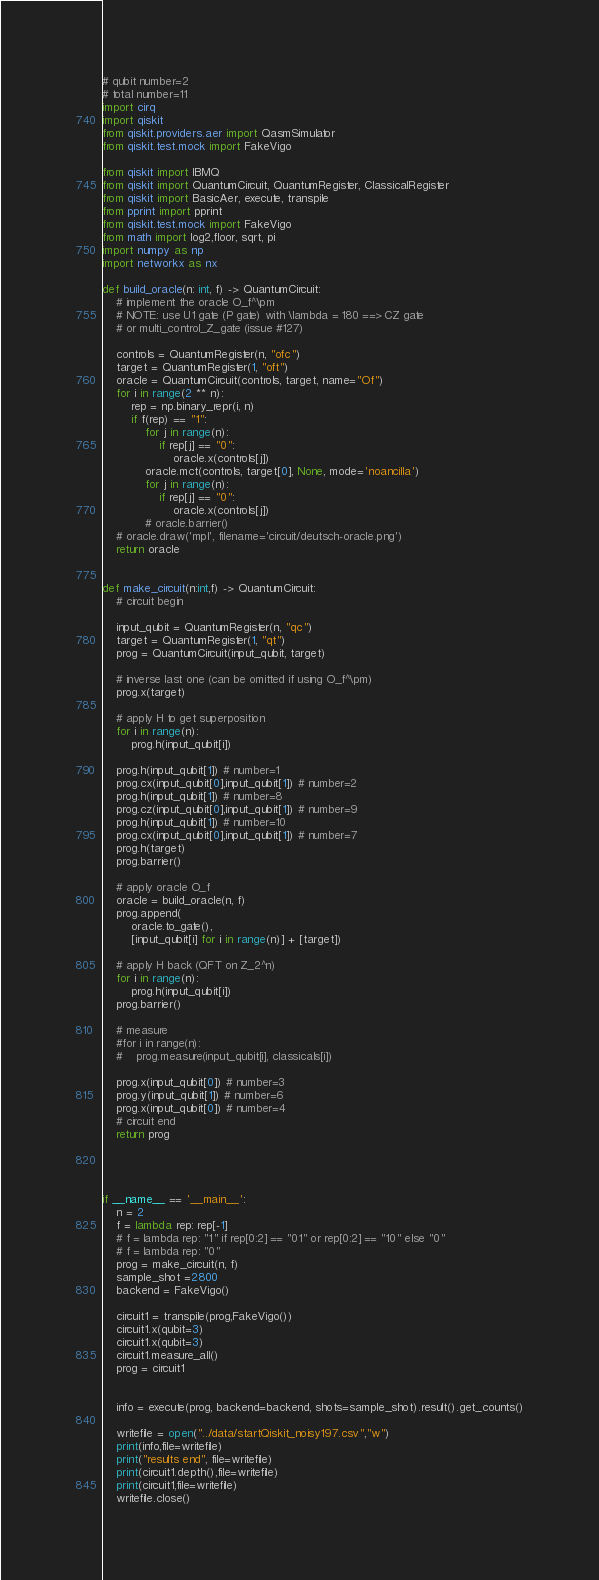Convert code to text. <code><loc_0><loc_0><loc_500><loc_500><_Python_># qubit number=2
# total number=11
import cirq
import qiskit
from qiskit.providers.aer import QasmSimulator
from qiskit.test.mock import FakeVigo

from qiskit import IBMQ
from qiskit import QuantumCircuit, QuantumRegister, ClassicalRegister
from qiskit import BasicAer, execute, transpile
from pprint import pprint
from qiskit.test.mock import FakeVigo
from math import log2,floor, sqrt, pi
import numpy as np
import networkx as nx

def build_oracle(n: int, f) -> QuantumCircuit:
    # implement the oracle O_f^\pm
    # NOTE: use U1 gate (P gate) with \lambda = 180 ==> CZ gate
    # or multi_control_Z_gate (issue #127)

    controls = QuantumRegister(n, "ofc")
    target = QuantumRegister(1, "oft")
    oracle = QuantumCircuit(controls, target, name="Of")
    for i in range(2 ** n):
        rep = np.binary_repr(i, n)
        if f(rep) == "1":
            for j in range(n):
                if rep[j] == "0":
                    oracle.x(controls[j])
            oracle.mct(controls, target[0], None, mode='noancilla')
            for j in range(n):
                if rep[j] == "0":
                    oracle.x(controls[j])
            # oracle.barrier()
    # oracle.draw('mpl', filename='circuit/deutsch-oracle.png')
    return oracle


def make_circuit(n:int,f) -> QuantumCircuit:
    # circuit begin

    input_qubit = QuantumRegister(n, "qc")
    target = QuantumRegister(1, "qt")
    prog = QuantumCircuit(input_qubit, target)

    # inverse last one (can be omitted if using O_f^\pm)
    prog.x(target)

    # apply H to get superposition
    for i in range(n):
        prog.h(input_qubit[i])

    prog.h(input_qubit[1]) # number=1
    prog.cx(input_qubit[0],input_qubit[1]) # number=2
    prog.h(input_qubit[1]) # number=8
    prog.cz(input_qubit[0],input_qubit[1]) # number=9
    prog.h(input_qubit[1]) # number=10
    prog.cx(input_qubit[0],input_qubit[1]) # number=7
    prog.h(target)
    prog.barrier()

    # apply oracle O_f
    oracle = build_oracle(n, f)
    prog.append(
        oracle.to_gate(),
        [input_qubit[i] for i in range(n)] + [target])

    # apply H back (QFT on Z_2^n)
    for i in range(n):
        prog.h(input_qubit[i])
    prog.barrier()

    # measure
    #for i in range(n):
    #    prog.measure(input_qubit[i], classicals[i])

    prog.x(input_qubit[0]) # number=3
    prog.y(input_qubit[1]) # number=6
    prog.x(input_qubit[0]) # number=4
    # circuit end
    return prog




if __name__ == '__main__':
    n = 2
    f = lambda rep: rep[-1]
    # f = lambda rep: "1" if rep[0:2] == "01" or rep[0:2] == "10" else "0"
    # f = lambda rep: "0"
    prog = make_circuit(n, f)
    sample_shot =2800
    backend = FakeVigo()

    circuit1 = transpile(prog,FakeVigo())
    circuit1.x(qubit=3)
    circuit1.x(qubit=3)
    circuit1.measure_all()
    prog = circuit1


    info = execute(prog, backend=backend, shots=sample_shot).result().get_counts()

    writefile = open("../data/startQiskit_noisy197.csv","w")
    print(info,file=writefile)
    print("results end", file=writefile)
    print(circuit1.depth(),file=writefile)
    print(circuit1,file=writefile)
    writefile.close()
</code> 